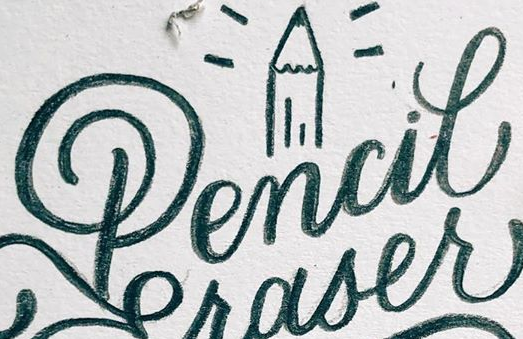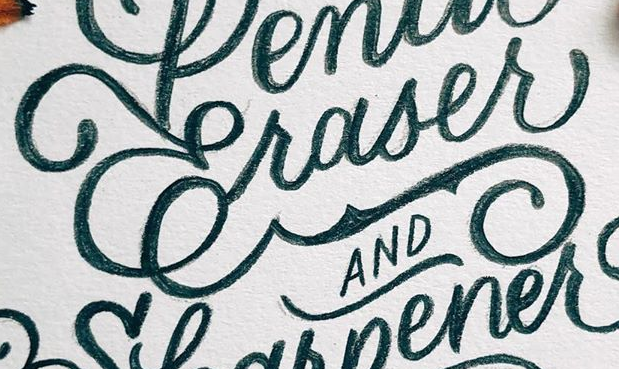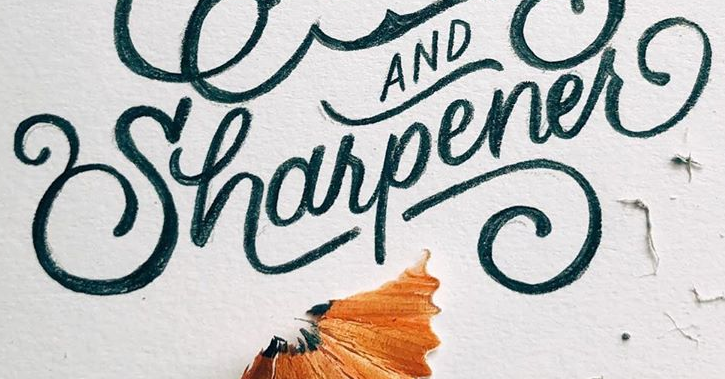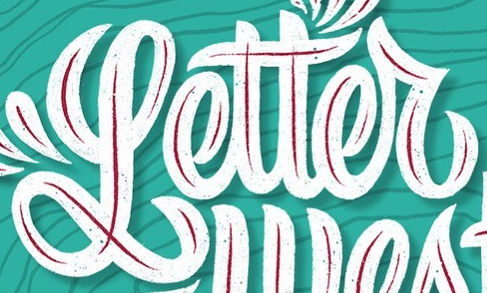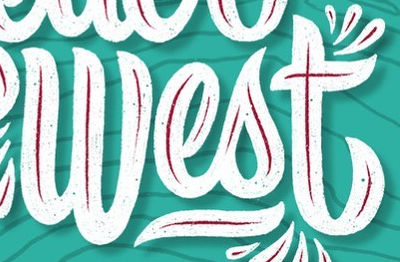What words are shown in these images in order, separated by a semicolon? Pencil; Craser; Uharpener; Letter; West 